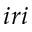Convert formula to latex. <formula><loc_0><loc_0><loc_500><loc_500>i r i</formula> 